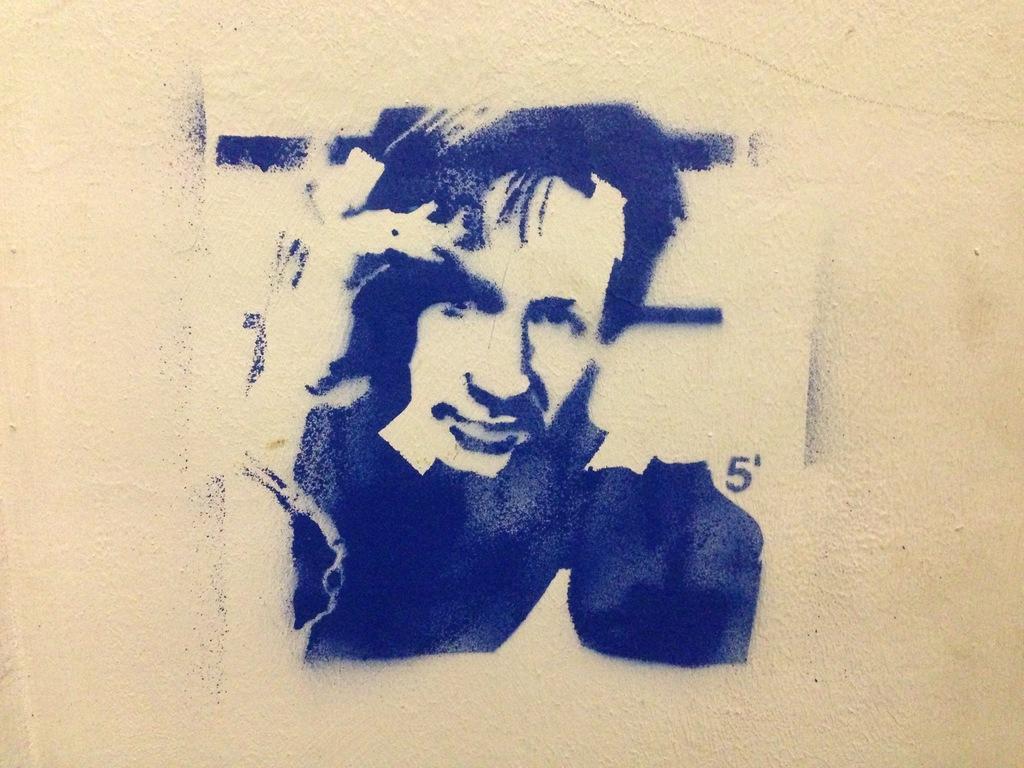In one or two sentences, can you explain what this image depicts? In this image there is a wall, and on the wall there is some graffiti. 